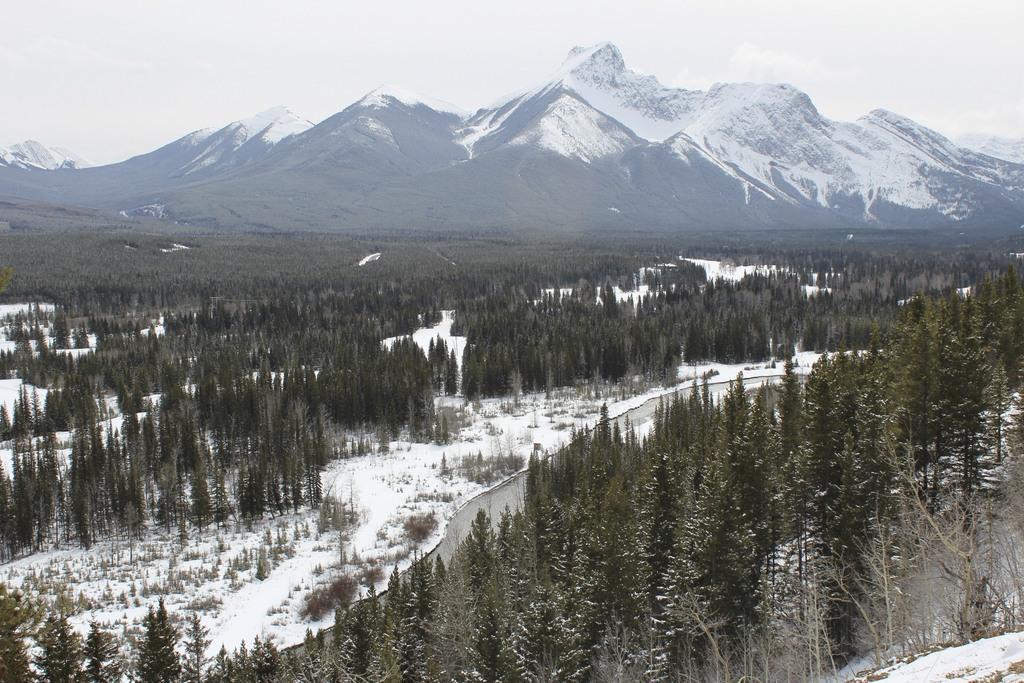In one or two sentences, can you explain what this image depicts? Here we can see trees and snow. Background we can see mountain and sky. 